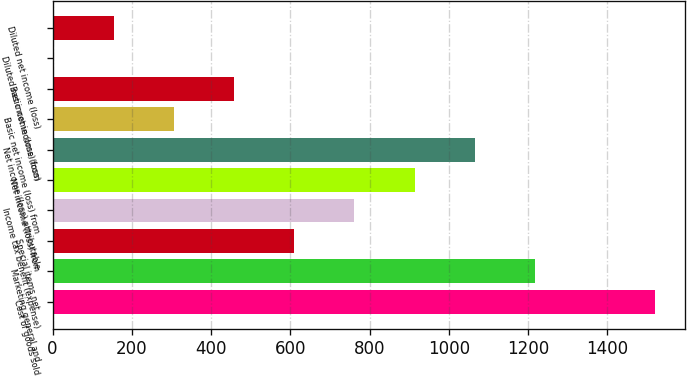Convert chart. <chart><loc_0><loc_0><loc_500><loc_500><bar_chart><fcel>Cost of goods sold<fcel>Marketing general and<fcel>Special items net<fcel>Income tax benefit (expense)<fcel>Net income (loss) from<fcel>Net income (loss) attributable<fcel>Basic net income (loss) from<fcel>Basic net income (loss)<fcel>Diluted net income (loss) from<fcel>Diluted net income (loss)<nl><fcel>1520.3<fcel>1216.76<fcel>609.72<fcel>761.48<fcel>913.24<fcel>1065<fcel>306.2<fcel>457.96<fcel>2.68<fcel>154.44<nl></chart> 